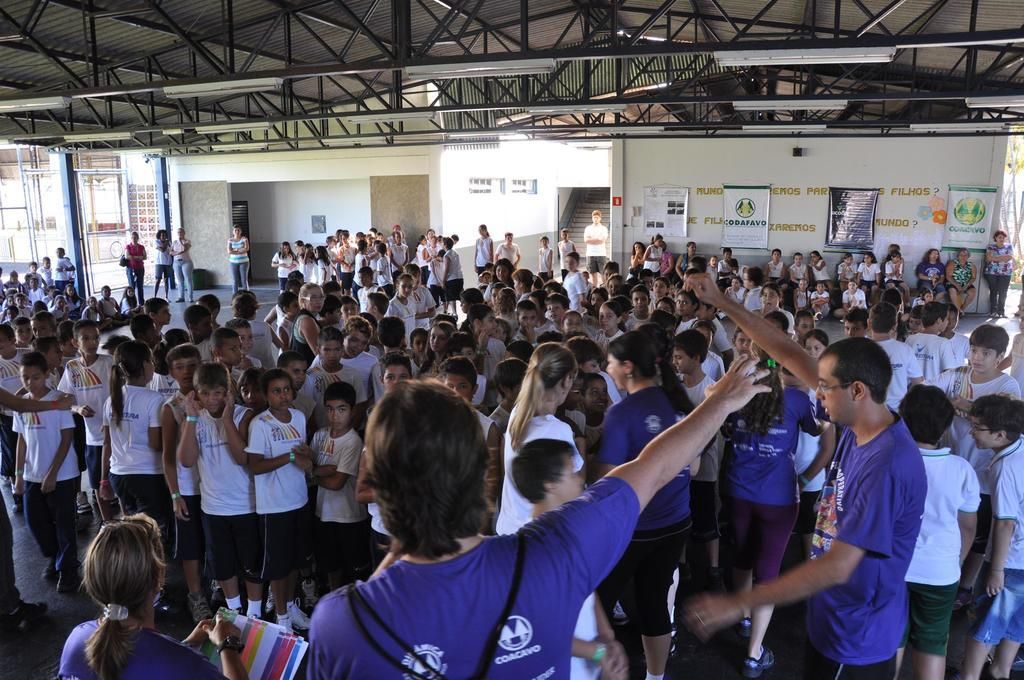What are the people in the image doing? The people in the image are standing on the floor. What can be seen in the background of the image? In the background of the image, there are advertisements, a staircase, sign boards, and grills. How are the advertisements positioned in the image? The advertisements are attached to walls in the background of the image. Can you see a cat playing with a monkey in the image? There is no cat or monkey present in the image. Is it raining sleet in the image? The image does not show any weather conditions, so it cannot be determined if it is raining sleet. 